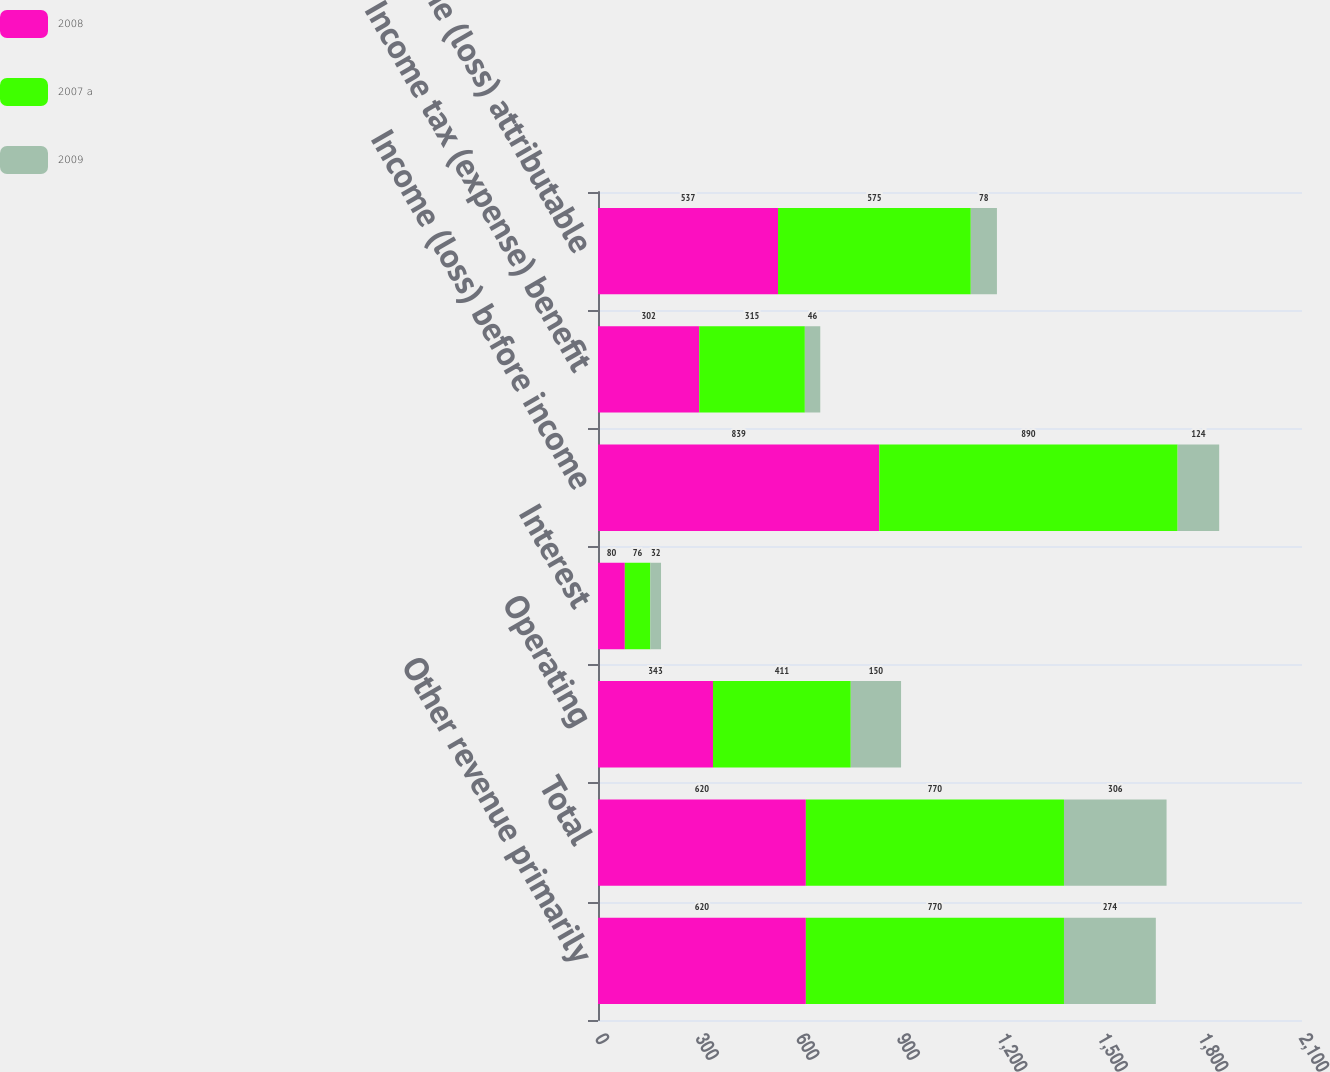Convert chart to OTSL. <chart><loc_0><loc_0><loc_500><loc_500><stacked_bar_chart><ecel><fcel>Other revenue primarily<fcel>Total<fcel>Operating<fcel>Interest<fcel>Income (loss) before income<fcel>Income tax (expense) benefit<fcel>Net income (loss) attributable<nl><fcel>2008<fcel>620<fcel>620<fcel>343<fcel>80<fcel>839<fcel>302<fcel>537<nl><fcel>2007 a<fcel>770<fcel>770<fcel>411<fcel>76<fcel>890<fcel>315<fcel>575<nl><fcel>2009<fcel>274<fcel>306<fcel>150<fcel>32<fcel>124<fcel>46<fcel>78<nl></chart> 